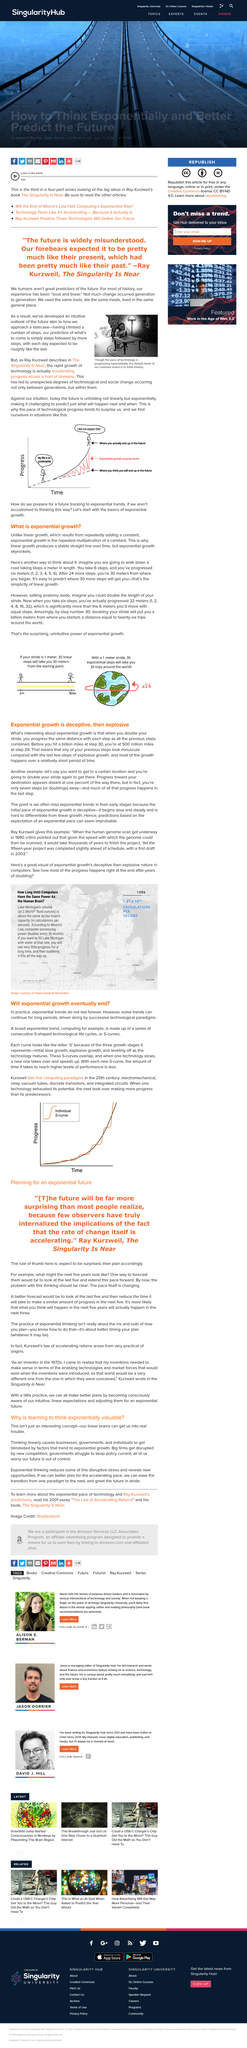Indicate a few pertinent items in this graphic. The three stages of an S curve are initial slow growth, explosive growth, and leveling off as technology matures. Exponential growth multiplies a constant, not adding a constant. Early on, we often miss exponential trends because the initial pace of exponential growth can be deceptive. The predictions based on the expectation of an exponential pace can seem highly unlikely. Exponential growth is a rapid and exponential increase in the number of organisms in a population over time, which can skyrocket to uncontrollable levels if not properly managed. Whether it is liner growth or exponential growth, it is important to understand and monitor the growth patterns of organisms in order to prevent overconsumption of resources and the potential collapse of the ecosystem. 